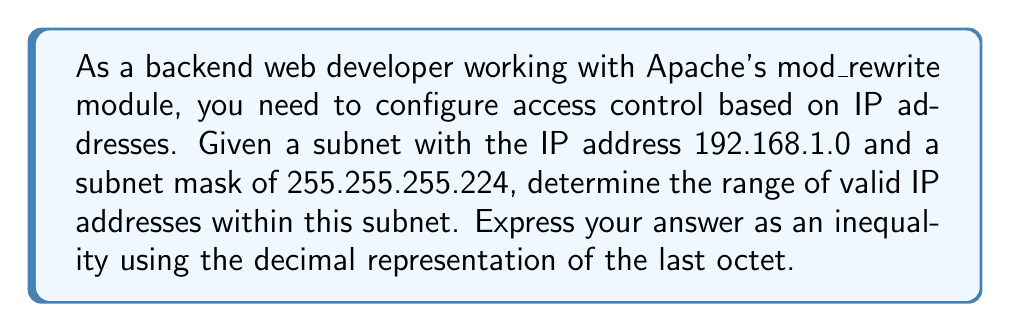Show me your answer to this math problem. To solve this problem, we need to follow these steps:

1. Identify the network and host portions of the IP address:
   The subnet mask 255.255.255.224 in binary is 11111111.11111111.11111111.11100000
   This means the last 5 bits are for host addressing.

2. Calculate the network address:
   192.168.1.0 AND 255.255.255.224 = 192.168.1.0

3. Calculate the broadcast address:
   192.168.1.0 OR 0.0.0.31 = 192.168.1.31

4. Determine the range of valid IP addresses:
   The valid IP addresses are between the network address and the broadcast address, excluding these two.

   First valid IP: 192.168.1.1
   Last valid IP: 192.168.1.30

5. Express the range as an inequality:
   Let $x$ represent the last octet of the IP address.
   The inequality can be written as:

   $$1 \leq x \leq 30$$

This inequality represents all valid host IP addresses within the given subnet.

In the context of mod_rewrite, you could use this information to create rules that allow or deny access based on IP ranges. For example:

```
RewriteCond %{REMOTE_ADDR} ^192\.168\.1\.([1-9]|[12][0-9]|30)$
RewriteRule ^(.*)$ - [F]
```

This rule would block access for all IPs in the valid range of the subnet.
Answer: $$1 \leq x \leq 30$$, where $x$ is the last octet of the IP address. 